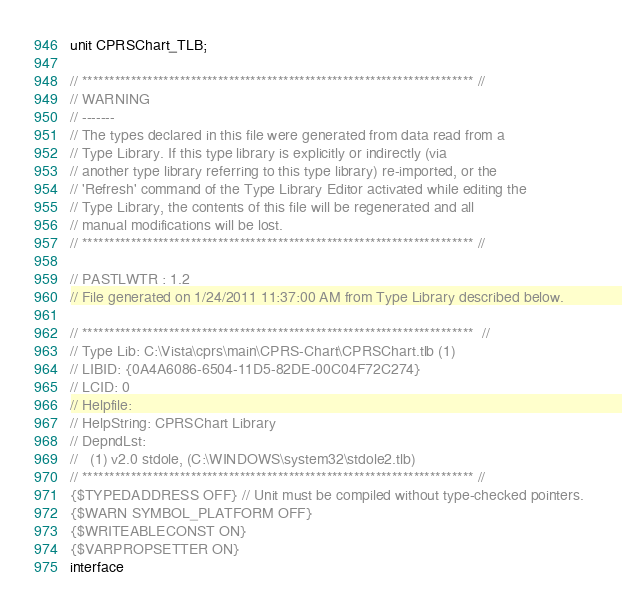<code> <loc_0><loc_0><loc_500><loc_500><_Pascal_>unit CPRSChart_TLB;

// ************************************************************************ //
// WARNING                                                                    
// -------                                                                    
// The types declared in this file were generated from data read from a       
// Type Library. If this type library is explicitly or indirectly (via        
// another type library referring to this type library) re-imported, or the   
// 'Refresh' command of the Type Library Editor activated while editing the   
// Type Library, the contents of this file will be regenerated and all        
// manual modifications will be lost.                                         
// ************************************************************************ //

// PASTLWTR : 1.2
// File generated on 1/24/2011 11:37:00 AM from Type Library described below.

// ************************************************************************  //
// Type Lib: C:\Vista\cprs\main\CPRS-Chart\CPRSChart.tlb (1)
// LIBID: {0A4A6086-6504-11D5-82DE-00C04F72C274}
// LCID: 0
// Helpfile: 
// HelpString: CPRSChart Library
// DepndLst: 
//   (1) v2.0 stdole, (C:\WINDOWS\system32\stdole2.tlb)
// ************************************************************************ //
{$TYPEDADDRESS OFF} // Unit must be compiled without type-checked pointers. 
{$WARN SYMBOL_PLATFORM OFF}
{$WRITEABLECONST ON}
{$VARPROPSETTER ON}
interface
</code> 